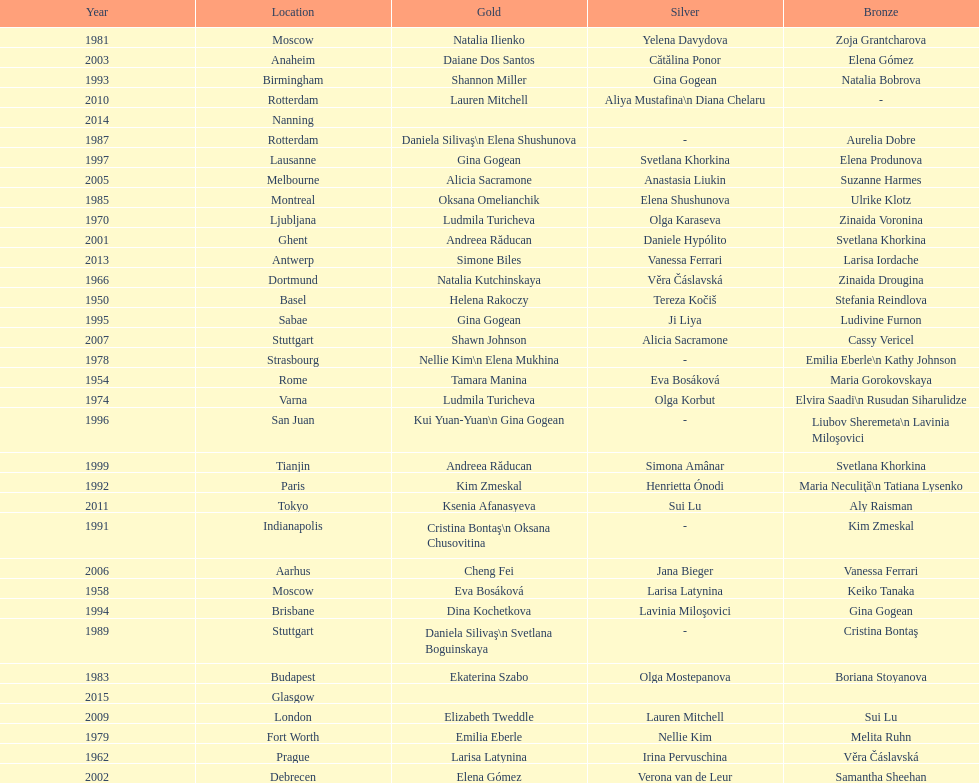How many times was the world artistic gymnastics championships held in the united states? 3. 